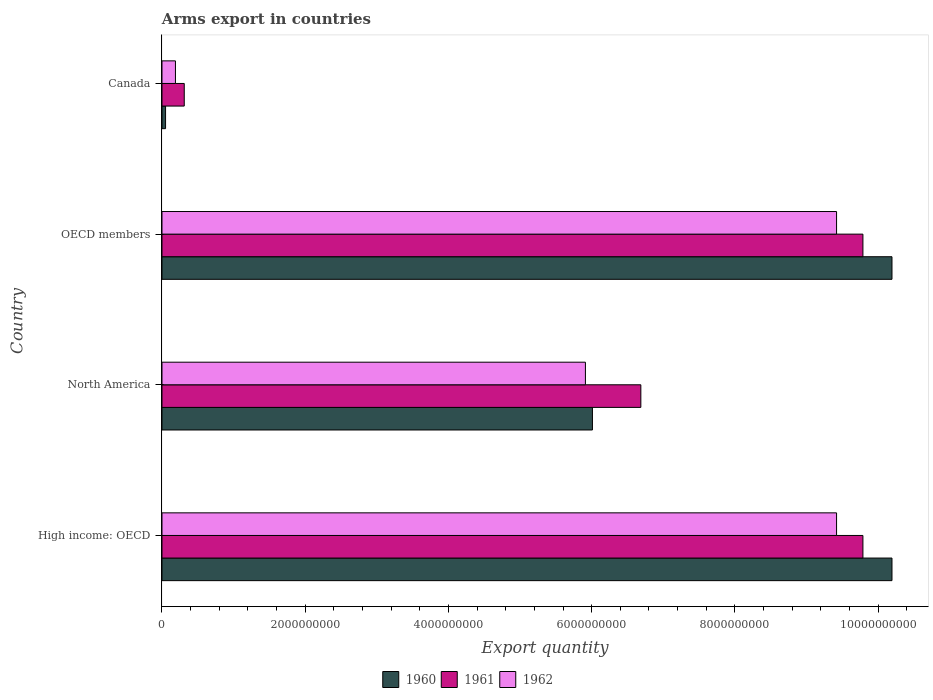How many different coloured bars are there?
Provide a short and direct response. 3. How many bars are there on the 1st tick from the bottom?
Your response must be concise. 3. In how many cases, is the number of bars for a given country not equal to the number of legend labels?
Keep it short and to the point. 0. What is the total arms export in 1960 in High income: OECD?
Offer a very short reply. 1.02e+1. Across all countries, what is the maximum total arms export in 1961?
Offer a very short reply. 9.79e+09. Across all countries, what is the minimum total arms export in 1962?
Ensure brevity in your answer.  1.88e+08. In which country was the total arms export in 1962 maximum?
Offer a terse response. High income: OECD. In which country was the total arms export in 1961 minimum?
Your answer should be very brief. Canada. What is the total total arms export in 1961 in the graph?
Your answer should be compact. 2.66e+1. What is the difference between the total arms export in 1960 in High income: OECD and that in OECD members?
Keep it short and to the point. 0. What is the difference between the total arms export in 1962 in North America and the total arms export in 1960 in OECD members?
Provide a succinct answer. -4.28e+09. What is the average total arms export in 1962 per country?
Provide a short and direct response. 6.24e+09. What is the difference between the total arms export in 1962 and total arms export in 1960 in North America?
Your answer should be compact. -9.80e+07. In how many countries, is the total arms export in 1961 greater than 8000000000 ?
Offer a very short reply. 2. What is the ratio of the total arms export in 1962 in Canada to that in High income: OECD?
Provide a succinct answer. 0.02. Is the difference between the total arms export in 1962 in Canada and OECD members greater than the difference between the total arms export in 1960 in Canada and OECD members?
Your answer should be very brief. Yes. What is the difference between the highest and the second highest total arms export in 1960?
Make the answer very short. 0. What is the difference between the highest and the lowest total arms export in 1961?
Provide a succinct answer. 9.48e+09. In how many countries, is the total arms export in 1960 greater than the average total arms export in 1960 taken over all countries?
Your response must be concise. 2. What does the 3rd bar from the top in High income: OECD represents?
Make the answer very short. 1960. Are all the bars in the graph horizontal?
Make the answer very short. Yes. What is the difference between two consecutive major ticks on the X-axis?
Your response must be concise. 2.00e+09. How are the legend labels stacked?
Provide a succinct answer. Horizontal. What is the title of the graph?
Provide a short and direct response. Arms export in countries. What is the label or title of the X-axis?
Make the answer very short. Export quantity. What is the Export quantity in 1960 in High income: OECD?
Your answer should be compact. 1.02e+1. What is the Export quantity in 1961 in High income: OECD?
Offer a very short reply. 9.79e+09. What is the Export quantity of 1962 in High income: OECD?
Ensure brevity in your answer.  9.42e+09. What is the Export quantity in 1960 in North America?
Your answer should be compact. 6.01e+09. What is the Export quantity in 1961 in North America?
Offer a terse response. 6.69e+09. What is the Export quantity of 1962 in North America?
Offer a very short reply. 5.91e+09. What is the Export quantity in 1960 in OECD members?
Keep it short and to the point. 1.02e+1. What is the Export quantity of 1961 in OECD members?
Your answer should be very brief. 9.79e+09. What is the Export quantity in 1962 in OECD members?
Your response must be concise. 9.42e+09. What is the Export quantity in 1961 in Canada?
Offer a terse response. 3.11e+08. What is the Export quantity in 1962 in Canada?
Make the answer very short. 1.88e+08. Across all countries, what is the maximum Export quantity of 1960?
Your response must be concise. 1.02e+1. Across all countries, what is the maximum Export quantity in 1961?
Offer a very short reply. 9.79e+09. Across all countries, what is the maximum Export quantity of 1962?
Offer a terse response. 9.42e+09. Across all countries, what is the minimum Export quantity in 1961?
Ensure brevity in your answer.  3.11e+08. Across all countries, what is the minimum Export quantity in 1962?
Your response must be concise. 1.88e+08. What is the total Export quantity of 1960 in the graph?
Offer a terse response. 2.64e+1. What is the total Export quantity in 1961 in the graph?
Your answer should be compact. 2.66e+1. What is the total Export quantity of 1962 in the graph?
Your answer should be very brief. 2.49e+1. What is the difference between the Export quantity of 1960 in High income: OECD and that in North America?
Your answer should be compact. 4.18e+09. What is the difference between the Export quantity in 1961 in High income: OECD and that in North America?
Your answer should be compact. 3.10e+09. What is the difference between the Export quantity of 1962 in High income: OECD and that in North America?
Give a very brief answer. 3.51e+09. What is the difference between the Export quantity in 1960 in High income: OECD and that in OECD members?
Your answer should be compact. 0. What is the difference between the Export quantity in 1960 in High income: OECD and that in Canada?
Provide a short and direct response. 1.01e+1. What is the difference between the Export quantity of 1961 in High income: OECD and that in Canada?
Offer a very short reply. 9.48e+09. What is the difference between the Export quantity of 1962 in High income: OECD and that in Canada?
Make the answer very short. 9.23e+09. What is the difference between the Export quantity in 1960 in North America and that in OECD members?
Your answer should be very brief. -4.18e+09. What is the difference between the Export quantity of 1961 in North America and that in OECD members?
Your answer should be compact. -3.10e+09. What is the difference between the Export quantity in 1962 in North America and that in OECD members?
Offer a terse response. -3.51e+09. What is the difference between the Export quantity in 1960 in North America and that in Canada?
Offer a very short reply. 5.96e+09. What is the difference between the Export quantity in 1961 in North America and that in Canada?
Your answer should be compact. 6.38e+09. What is the difference between the Export quantity of 1962 in North America and that in Canada?
Offer a very short reply. 5.72e+09. What is the difference between the Export quantity of 1960 in OECD members and that in Canada?
Your response must be concise. 1.01e+1. What is the difference between the Export quantity in 1961 in OECD members and that in Canada?
Provide a short and direct response. 9.48e+09. What is the difference between the Export quantity of 1962 in OECD members and that in Canada?
Ensure brevity in your answer.  9.23e+09. What is the difference between the Export quantity of 1960 in High income: OECD and the Export quantity of 1961 in North America?
Provide a short and direct response. 3.51e+09. What is the difference between the Export quantity of 1960 in High income: OECD and the Export quantity of 1962 in North America?
Your answer should be compact. 4.28e+09. What is the difference between the Export quantity in 1961 in High income: OECD and the Export quantity in 1962 in North America?
Offer a terse response. 3.88e+09. What is the difference between the Export quantity of 1960 in High income: OECD and the Export quantity of 1961 in OECD members?
Keep it short and to the point. 4.06e+08. What is the difference between the Export quantity of 1960 in High income: OECD and the Export quantity of 1962 in OECD members?
Provide a short and direct response. 7.74e+08. What is the difference between the Export quantity of 1961 in High income: OECD and the Export quantity of 1962 in OECD members?
Give a very brief answer. 3.68e+08. What is the difference between the Export quantity of 1960 in High income: OECD and the Export quantity of 1961 in Canada?
Ensure brevity in your answer.  9.88e+09. What is the difference between the Export quantity of 1960 in High income: OECD and the Export quantity of 1962 in Canada?
Your answer should be compact. 1.00e+1. What is the difference between the Export quantity in 1961 in High income: OECD and the Export quantity in 1962 in Canada?
Your answer should be compact. 9.60e+09. What is the difference between the Export quantity in 1960 in North America and the Export quantity in 1961 in OECD members?
Give a very brief answer. -3.78e+09. What is the difference between the Export quantity in 1960 in North America and the Export quantity in 1962 in OECD members?
Provide a succinct answer. -3.41e+09. What is the difference between the Export quantity in 1961 in North America and the Export quantity in 1962 in OECD members?
Give a very brief answer. -2.73e+09. What is the difference between the Export quantity in 1960 in North America and the Export quantity in 1961 in Canada?
Offer a very short reply. 5.70e+09. What is the difference between the Export quantity of 1960 in North America and the Export quantity of 1962 in Canada?
Make the answer very short. 5.82e+09. What is the difference between the Export quantity in 1961 in North America and the Export quantity in 1962 in Canada?
Keep it short and to the point. 6.50e+09. What is the difference between the Export quantity of 1960 in OECD members and the Export quantity of 1961 in Canada?
Give a very brief answer. 9.88e+09. What is the difference between the Export quantity of 1960 in OECD members and the Export quantity of 1962 in Canada?
Offer a very short reply. 1.00e+1. What is the difference between the Export quantity of 1961 in OECD members and the Export quantity of 1962 in Canada?
Your answer should be compact. 9.60e+09. What is the average Export quantity of 1960 per country?
Keep it short and to the point. 6.61e+09. What is the average Export quantity in 1961 per country?
Provide a succinct answer. 6.64e+09. What is the average Export quantity of 1962 per country?
Provide a succinct answer. 6.24e+09. What is the difference between the Export quantity of 1960 and Export quantity of 1961 in High income: OECD?
Offer a very short reply. 4.06e+08. What is the difference between the Export quantity of 1960 and Export quantity of 1962 in High income: OECD?
Your response must be concise. 7.74e+08. What is the difference between the Export quantity of 1961 and Export quantity of 1962 in High income: OECD?
Offer a terse response. 3.68e+08. What is the difference between the Export quantity of 1960 and Export quantity of 1961 in North America?
Your response must be concise. -6.76e+08. What is the difference between the Export quantity of 1960 and Export quantity of 1962 in North America?
Your response must be concise. 9.80e+07. What is the difference between the Export quantity in 1961 and Export quantity in 1962 in North America?
Keep it short and to the point. 7.74e+08. What is the difference between the Export quantity in 1960 and Export quantity in 1961 in OECD members?
Offer a very short reply. 4.06e+08. What is the difference between the Export quantity in 1960 and Export quantity in 1962 in OECD members?
Give a very brief answer. 7.74e+08. What is the difference between the Export quantity in 1961 and Export quantity in 1962 in OECD members?
Offer a very short reply. 3.68e+08. What is the difference between the Export quantity of 1960 and Export quantity of 1961 in Canada?
Give a very brief answer. -2.61e+08. What is the difference between the Export quantity of 1960 and Export quantity of 1962 in Canada?
Keep it short and to the point. -1.38e+08. What is the difference between the Export quantity in 1961 and Export quantity in 1962 in Canada?
Offer a very short reply. 1.23e+08. What is the ratio of the Export quantity in 1960 in High income: OECD to that in North America?
Make the answer very short. 1.7. What is the ratio of the Export quantity of 1961 in High income: OECD to that in North America?
Keep it short and to the point. 1.46. What is the ratio of the Export quantity of 1962 in High income: OECD to that in North America?
Offer a very short reply. 1.59. What is the ratio of the Export quantity of 1962 in High income: OECD to that in OECD members?
Provide a short and direct response. 1. What is the ratio of the Export quantity in 1960 in High income: OECD to that in Canada?
Provide a succinct answer. 203.88. What is the ratio of the Export quantity in 1961 in High income: OECD to that in Canada?
Your answer should be compact. 31.47. What is the ratio of the Export quantity of 1962 in High income: OECD to that in Canada?
Your response must be concise. 50.11. What is the ratio of the Export quantity in 1960 in North America to that in OECD members?
Ensure brevity in your answer.  0.59. What is the ratio of the Export quantity of 1961 in North America to that in OECD members?
Provide a succinct answer. 0.68. What is the ratio of the Export quantity in 1962 in North America to that in OECD members?
Ensure brevity in your answer.  0.63. What is the ratio of the Export quantity of 1960 in North America to that in Canada?
Ensure brevity in your answer.  120.22. What is the ratio of the Export quantity in 1961 in North America to that in Canada?
Your answer should be very brief. 21.5. What is the ratio of the Export quantity in 1962 in North America to that in Canada?
Your answer should be compact. 31.45. What is the ratio of the Export quantity of 1960 in OECD members to that in Canada?
Your answer should be very brief. 203.88. What is the ratio of the Export quantity in 1961 in OECD members to that in Canada?
Your response must be concise. 31.47. What is the ratio of the Export quantity in 1962 in OECD members to that in Canada?
Offer a very short reply. 50.11. What is the difference between the highest and the second highest Export quantity of 1961?
Your response must be concise. 0. What is the difference between the highest and the lowest Export quantity in 1960?
Make the answer very short. 1.01e+1. What is the difference between the highest and the lowest Export quantity of 1961?
Your response must be concise. 9.48e+09. What is the difference between the highest and the lowest Export quantity of 1962?
Offer a very short reply. 9.23e+09. 